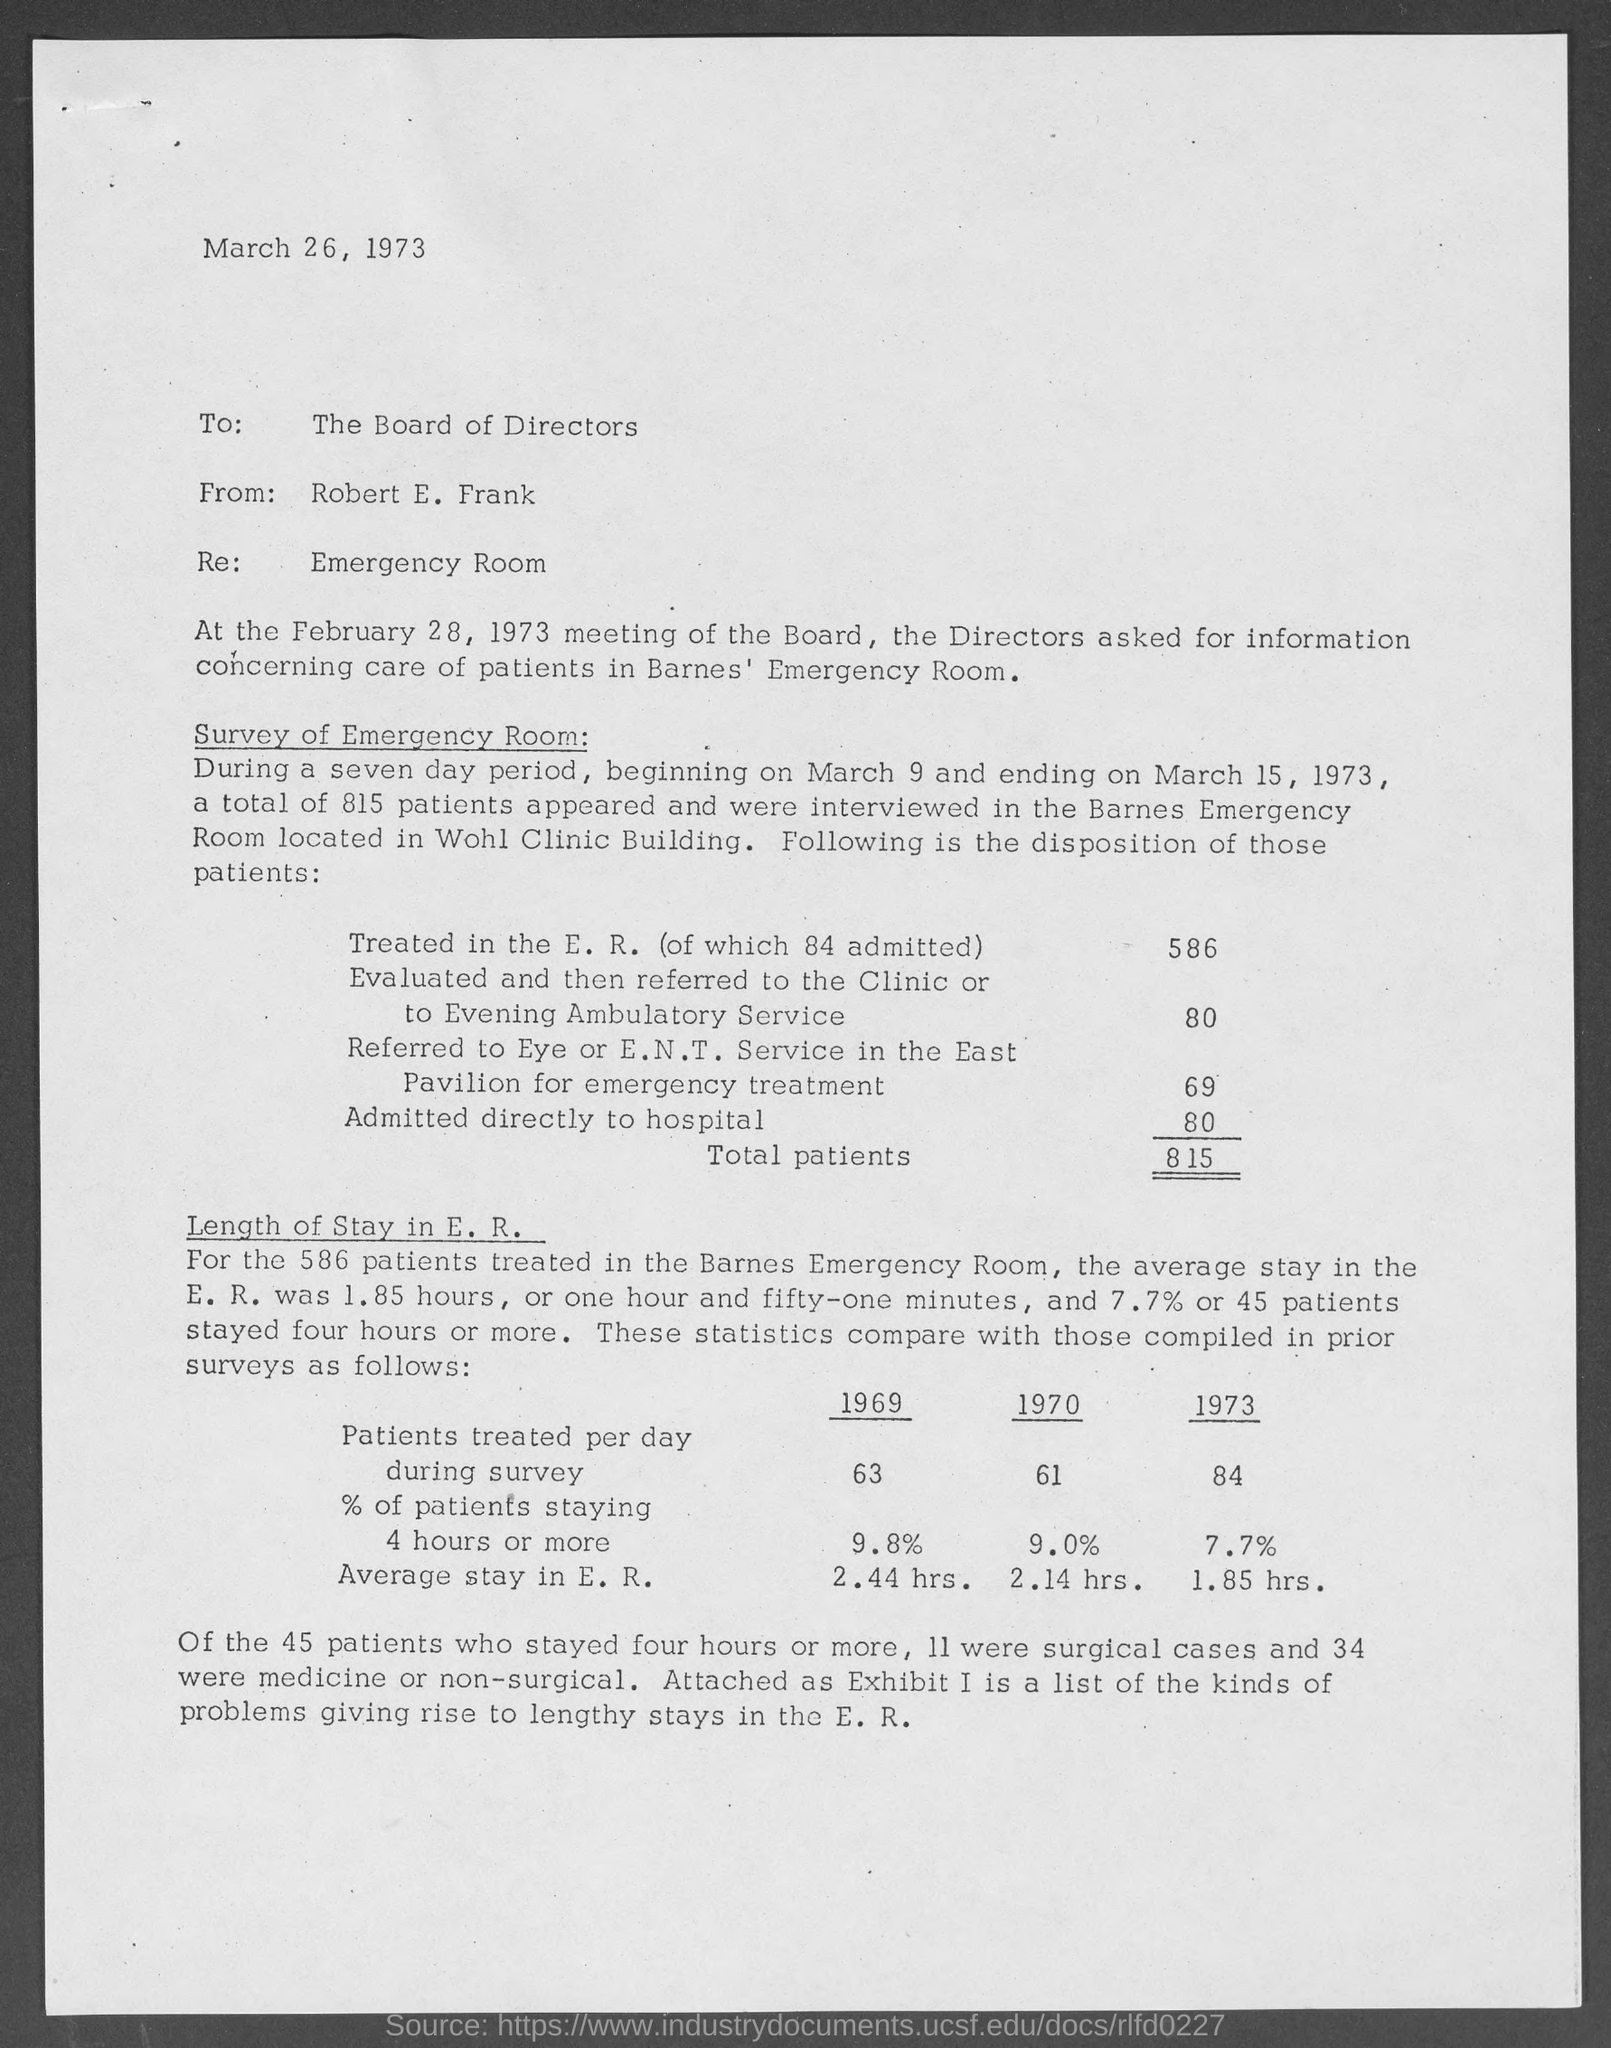Mention a couple of crucial points in this snapshot. There were a total of 815 patients. This memo is addressed to the board of directors. 